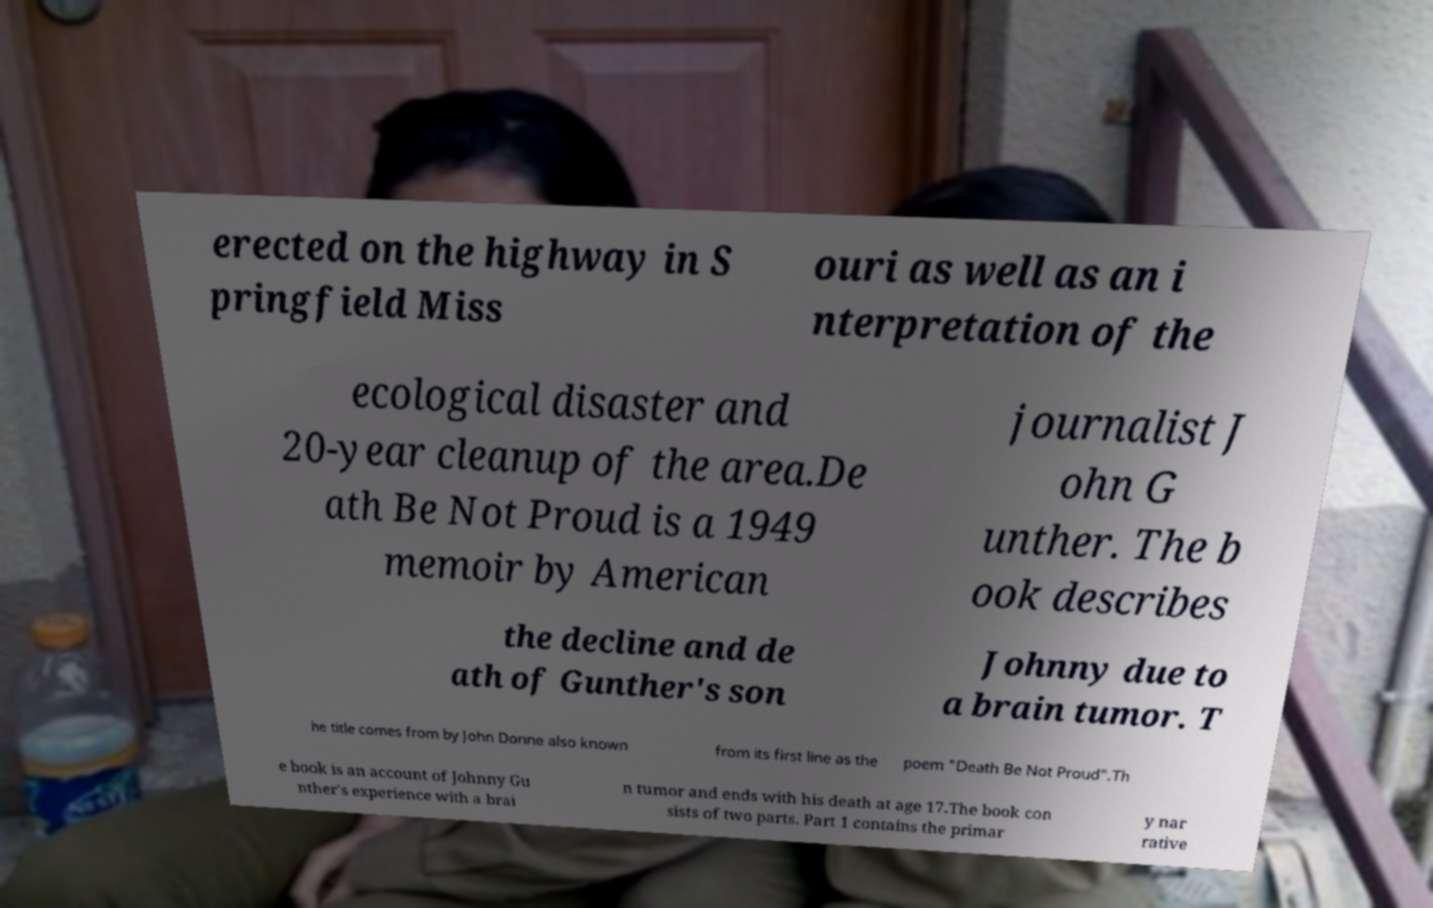What messages or text are displayed in this image? I need them in a readable, typed format. erected on the highway in S pringfield Miss ouri as well as an i nterpretation of the ecological disaster and 20-year cleanup of the area.De ath Be Not Proud is a 1949 memoir by American journalist J ohn G unther. The b ook describes the decline and de ath of Gunther's son Johnny due to a brain tumor. T he title comes from by John Donne also known from its first line as the poem "Death Be Not Proud".Th e book is an account of Johnny Gu nther's experience with a brai n tumor and ends with his death at age 17.The book con sists of two parts. Part 1 contains the primar y nar rative 